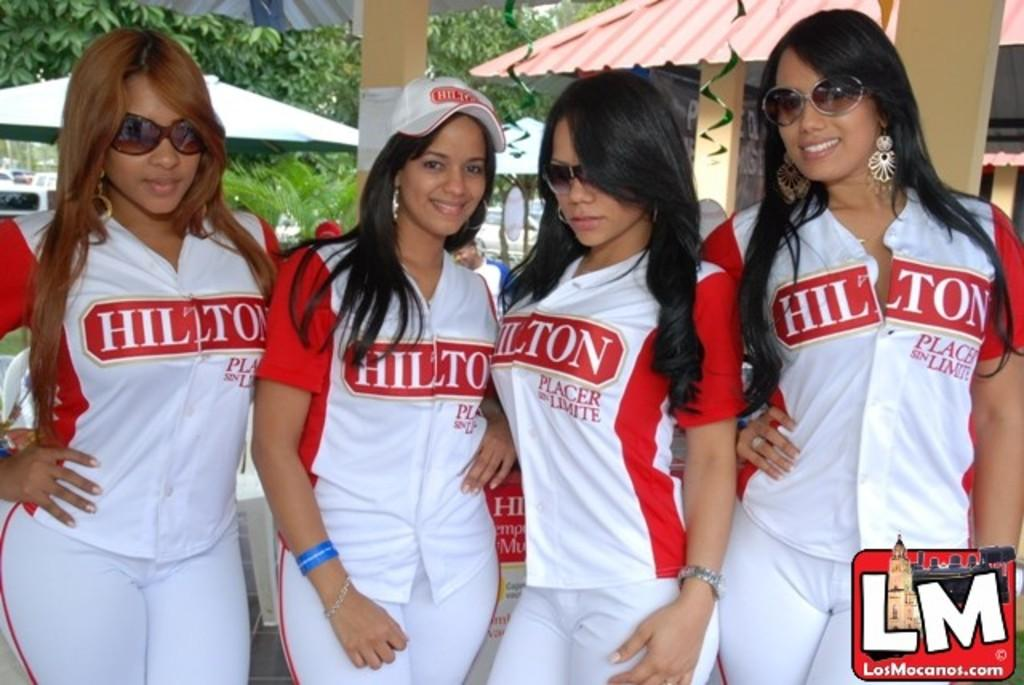<image>
Render a clear and concise summary of the photo. Four females wear red and white tops with Hilton on the front and pose for the camera. 